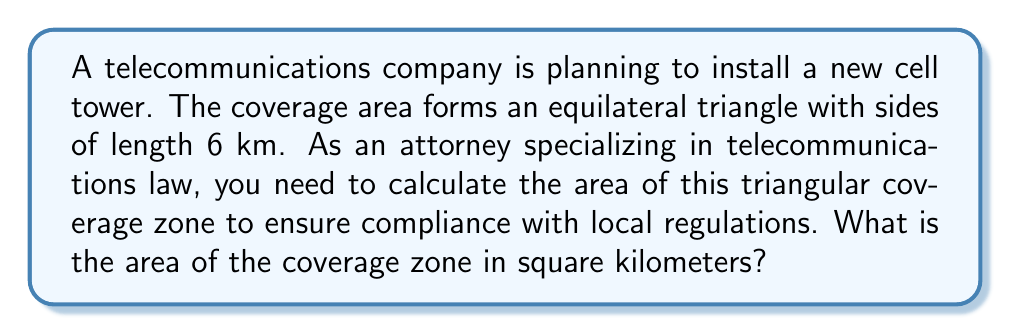Show me your answer to this math problem. Let's approach this step-by-step:

1) We know that the triangle is equilateral with side length 6 km.

2) The area of an equilateral triangle can be calculated using the formula:

   $$A = \frac{\sqrt{3}}{4}a^2$$

   where $A$ is the area and $a$ is the side length.

3) Substituting our side length of 6 km:

   $$A = \frac{\sqrt{3}}{4}(6)^2$$

4) Simplify the squared term:

   $$A = \frac{\sqrt{3}}{4}(36)$$

5) Multiply:

   $$A = 9\sqrt{3}$$

6) This gives us the exact answer in square kilometers.

7) If we need to approximate:

   $$A \approx 9 * 1.732 \approx 15.588 \text{ km}^2$$

[asy]
import geometry;

size(200);
pair A = (0,0), B = (6,0), C = (3,3*sqrt(3));
draw(A--B--C--cycle);
label("6 km", (A+B)/2, S);
label("6 km", (B+C)/2, SE);
label("6 km", (C+A)/2, NW);
label("A", (3,sqrt(3)), S);
[/asy]
Answer: $9\sqrt{3} \text{ km}^2$ 